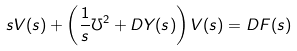Convert formula to latex. <formula><loc_0><loc_0><loc_500><loc_500>s V ( s ) + \left ( \frac { 1 } { s } \mho ^ { 2 } + D Y ( s ) \right ) V ( s ) = D F ( s )</formula> 